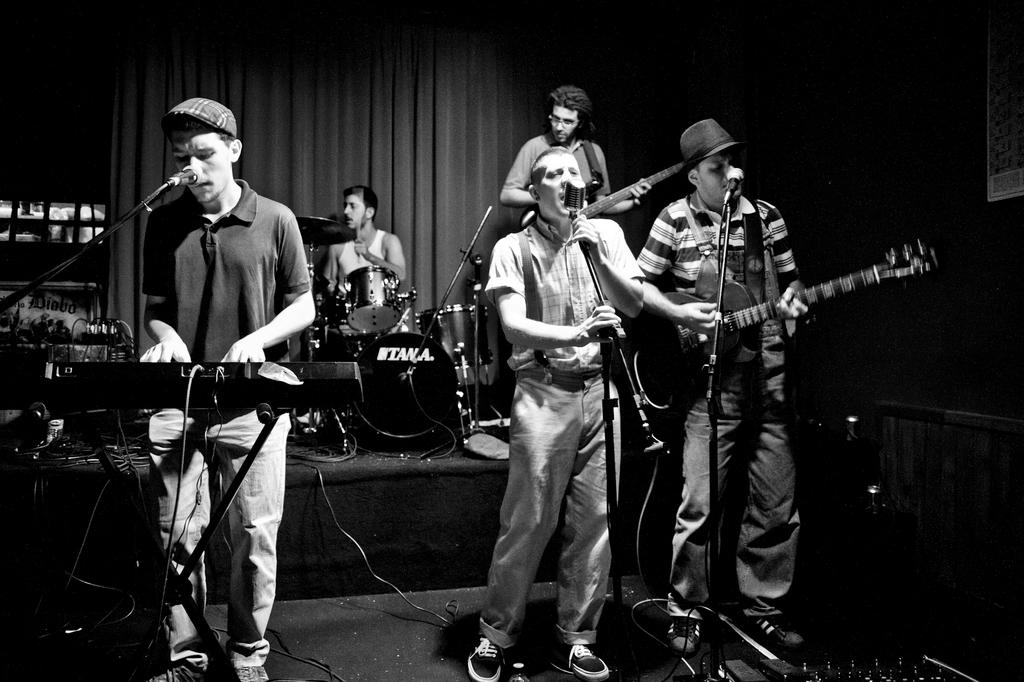How many people are in the image? There are 4 people in the image. What are the people doing in the image? The people are standing and playing musical instruments. Are the people singing in the image? Yes, the people are singing a song in the image. Which person is playing a specific instrument in the image? There is a person in the image who is beating drums. What type of credit card is visible in the image? There is no credit card present in the image. What color is the chalk used by the people in the image? There is no chalk present in the image; the people are playing musical instruments and singing a song. 